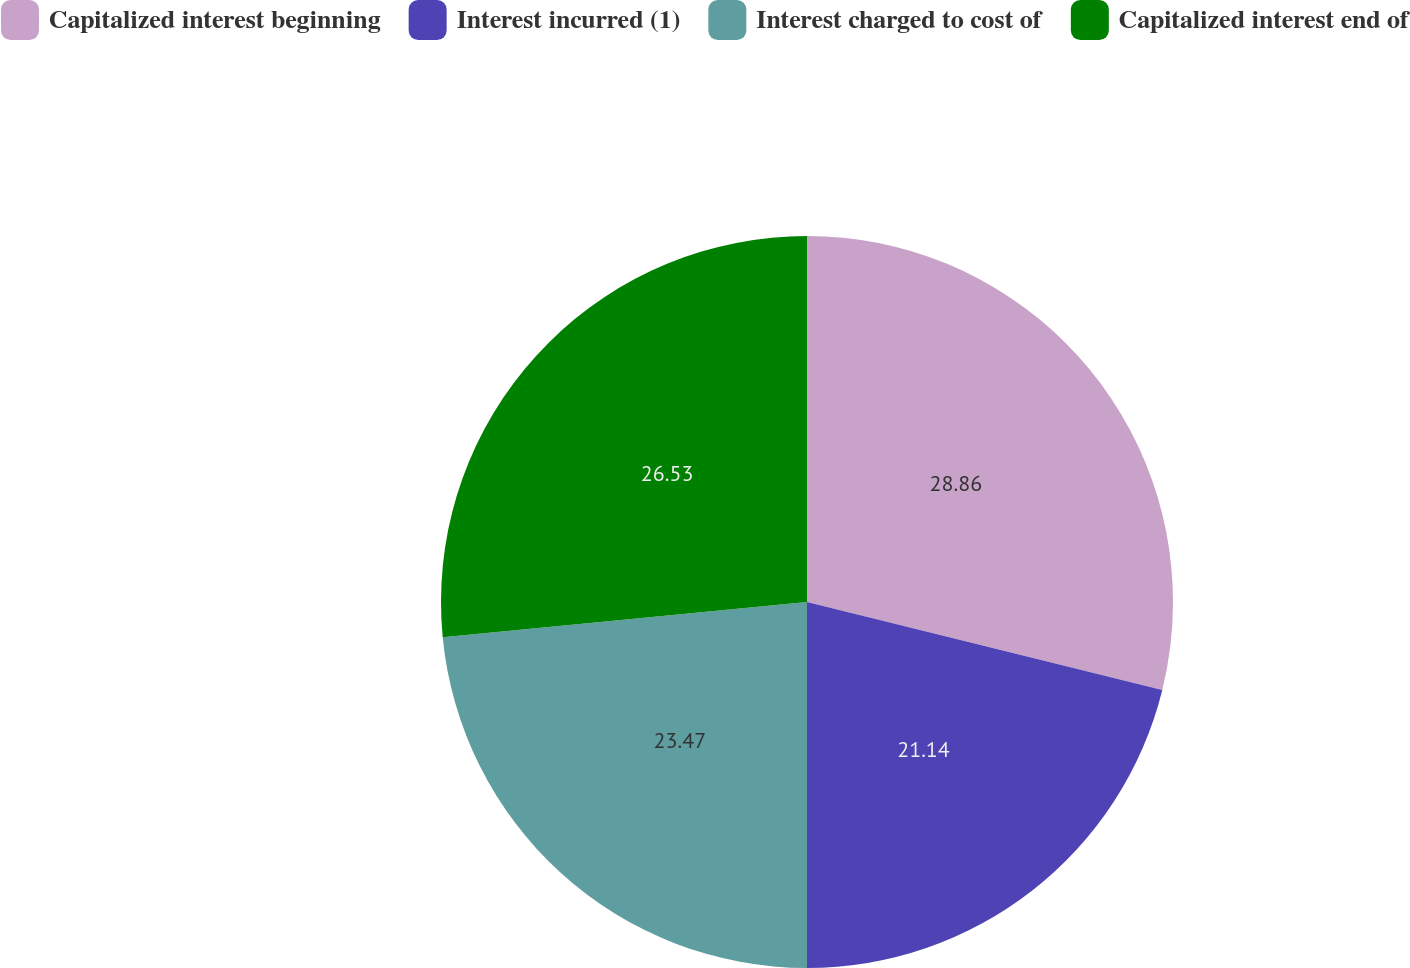<chart> <loc_0><loc_0><loc_500><loc_500><pie_chart><fcel>Capitalized interest beginning<fcel>Interest incurred (1)<fcel>Interest charged to cost of<fcel>Capitalized interest end of<nl><fcel>28.86%<fcel>21.14%<fcel>23.47%<fcel>26.53%<nl></chart> 